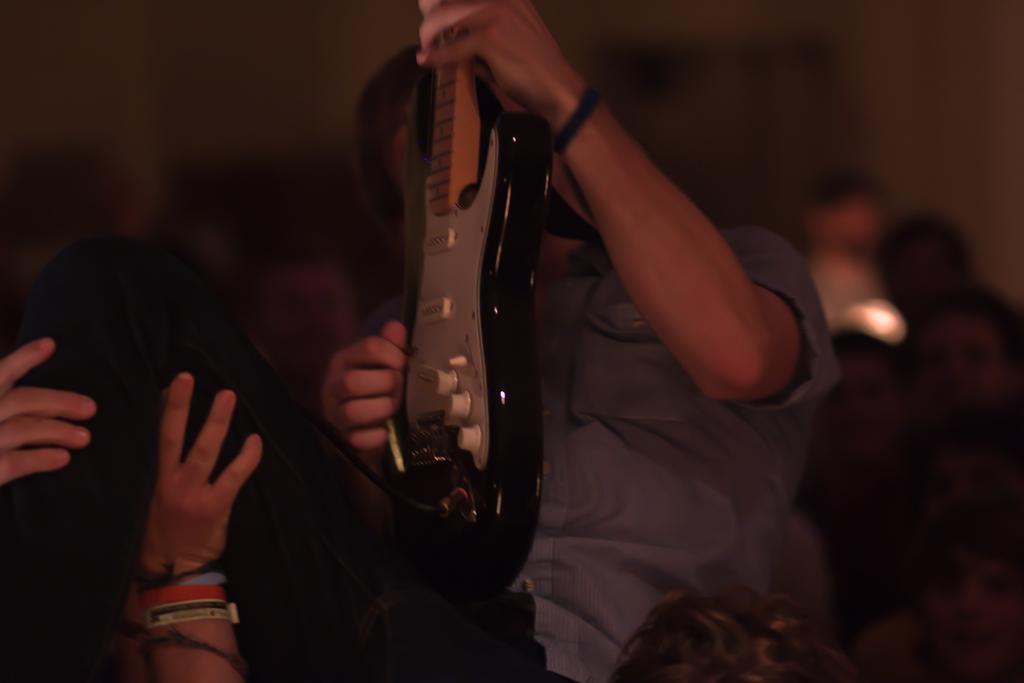Can you describe this image briefly? In this image there is a person lifting the other person and he is holding the guitar. Behind him there are a few other people. In the background of the image there is a wall. 